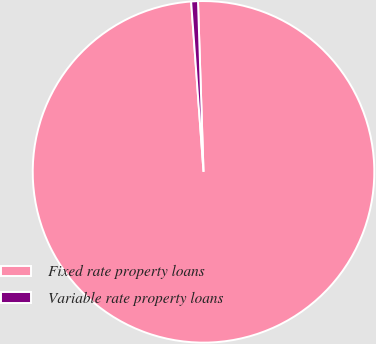Convert chart to OTSL. <chart><loc_0><loc_0><loc_500><loc_500><pie_chart><fcel>Fixed rate property loans<fcel>Variable rate property loans<nl><fcel>99.36%<fcel>0.64%<nl></chart> 